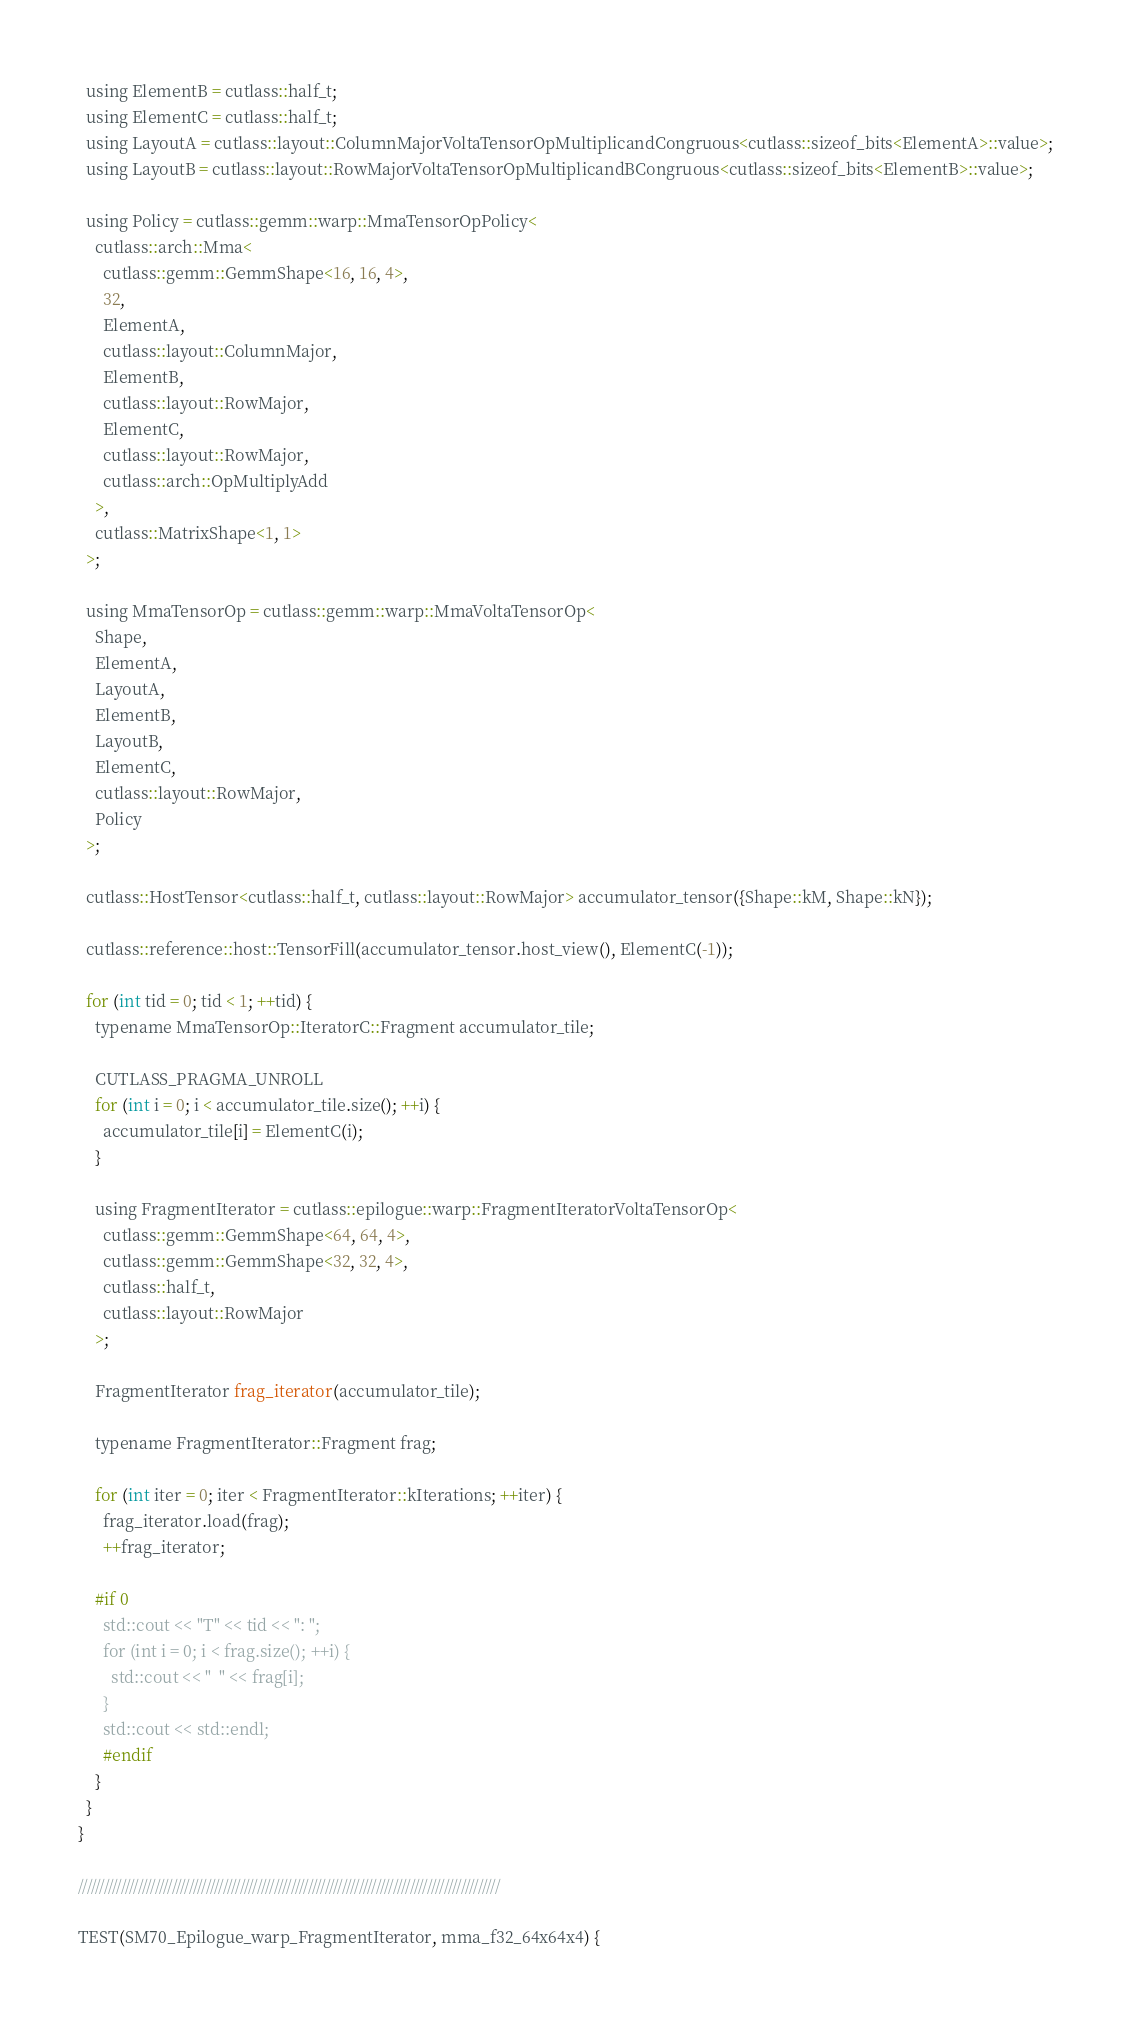Convert code to text. <code><loc_0><loc_0><loc_500><loc_500><_Cuda_>  using ElementB = cutlass::half_t;
  using ElementC = cutlass::half_t;
  using LayoutA = cutlass::layout::ColumnMajorVoltaTensorOpMultiplicandCongruous<cutlass::sizeof_bits<ElementA>::value>;
  using LayoutB = cutlass::layout::RowMajorVoltaTensorOpMultiplicandBCongruous<cutlass::sizeof_bits<ElementB>::value>;

  using Policy = cutlass::gemm::warp::MmaTensorOpPolicy<
    cutlass::arch::Mma<
      cutlass::gemm::GemmShape<16, 16, 4>,
      32,
      ElementA,
      cutlass::layout::ColumnMajor,
      ElementB,
      cutlass::layout::RowMajor,
      ElementC,
      cutlass::layout::RowMajor,
      cutlass::arch::OpMultiplyAdd
    >,
    cutlass::MatrixShape<1, 1>
  >;

  using MmaTensorOp = cutlass::gemm::warp::MmaVoltaTensorOp<
    Shape,
    ElementA,
    LayoutA,
    ElementB,
    LayoutB,
    ElementC,
    cutlass::layout::RowMajor,
    Policy
  >;

  cutlass::HostTensor<cutlass::half_t, cutlass::layout::RowMajor> accumulator_tensor({Shape::kM, Shape::kN});

  cutlass::reference::host::TensorFill(accumulator_tensor.host_view(), ElementC(-1));

  for (int tid = 0; tid < 1; ++tid) {
    typename MmaTensorOp::IteratorC::Fragment accumulator_tile;

    CUTLASS_PRAGMA_UNROLL
    for (int i = 0; i < accumulator_tile.size(); ++i) {
      accumulator_tile[i] = ElementC(i);
    }

    using FragmentIterator = cutlass::epilogue::warp::FragmentIteratorVoltaTensorOp<
      cutlass::gemm::GemmShape<64, 64, 4>,
      cutlass::gemm::GemmShape<32, 32, 4>,
      cutlass::half_t,
      cutlass::layout::RowMajor
    >; 

    FragmentIterator frag_iterator(accumulator_tile);

    typename FragmentIterator::Fragment frag;

    for (int iter = 0; iter < FragmentIterator::kIterations; ++iter) {
      frag_iterator.load(frag);
      ++frag_iterator;

    #if 0
      std::cout << "T" << tid << ": ";
      for (int i = 0; i < frag.size(); ++i) {
        std::cout << "  " << frag[i];
      }
      std::cout << std::endl;
      #endif
    }
  }
}

///////////////////////////////////////////////////////////////////////////////////////////////////

TEST(SM70_Epilogue_warp_FragmentIterator, mma_f32_64x64x4) {
</code> 